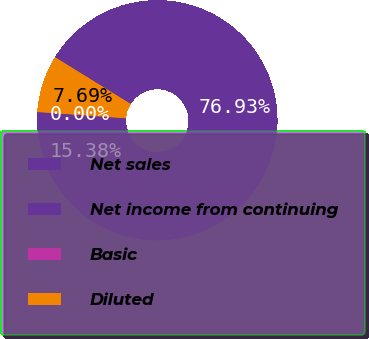Convert chart to OTSL. <chart><loc_0><loc_0><loc_500><loc_500><pie_chart><fcel>Net sales<fcel>Net income from continuing<fcel>Basic<fcel>Diluted<nl><fcel>76.92%<fcel>15.38%<fcel>0.0%<fcel>7.69%<nl></chart> 